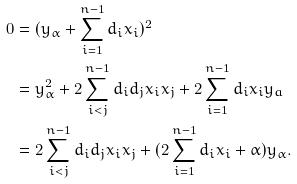Convert formula to latex. <formula><loc_0><loc_0><loc_500><loc_500>0 & = ( y _ { \alpha } + \sum _ { i = 1 } ^ { n - 1 } d _ { i } x _ { i } ) ^ { 2 } \\ & = y _ { \alpha } ^ { 2 } + 2 \sum _ { i < j } ^ { n - 1 } d _ { i } d _ { j } x _ { i } x _ { j } + 2 \sum _ { i = 1 } ^ { n - 1 } d _ { i } x _ { i } y _ { a } \\ & = 2 \sum _ { i < j } ^ { n - 1 } d _ { i } d _ { j } x _ { i } x _ { j } + ( 2 \sum _ { i = 1 } ^ { n - 1 } d _ { i } x _ { i } + \alpha ) y _ { \alpha } .</formula> 